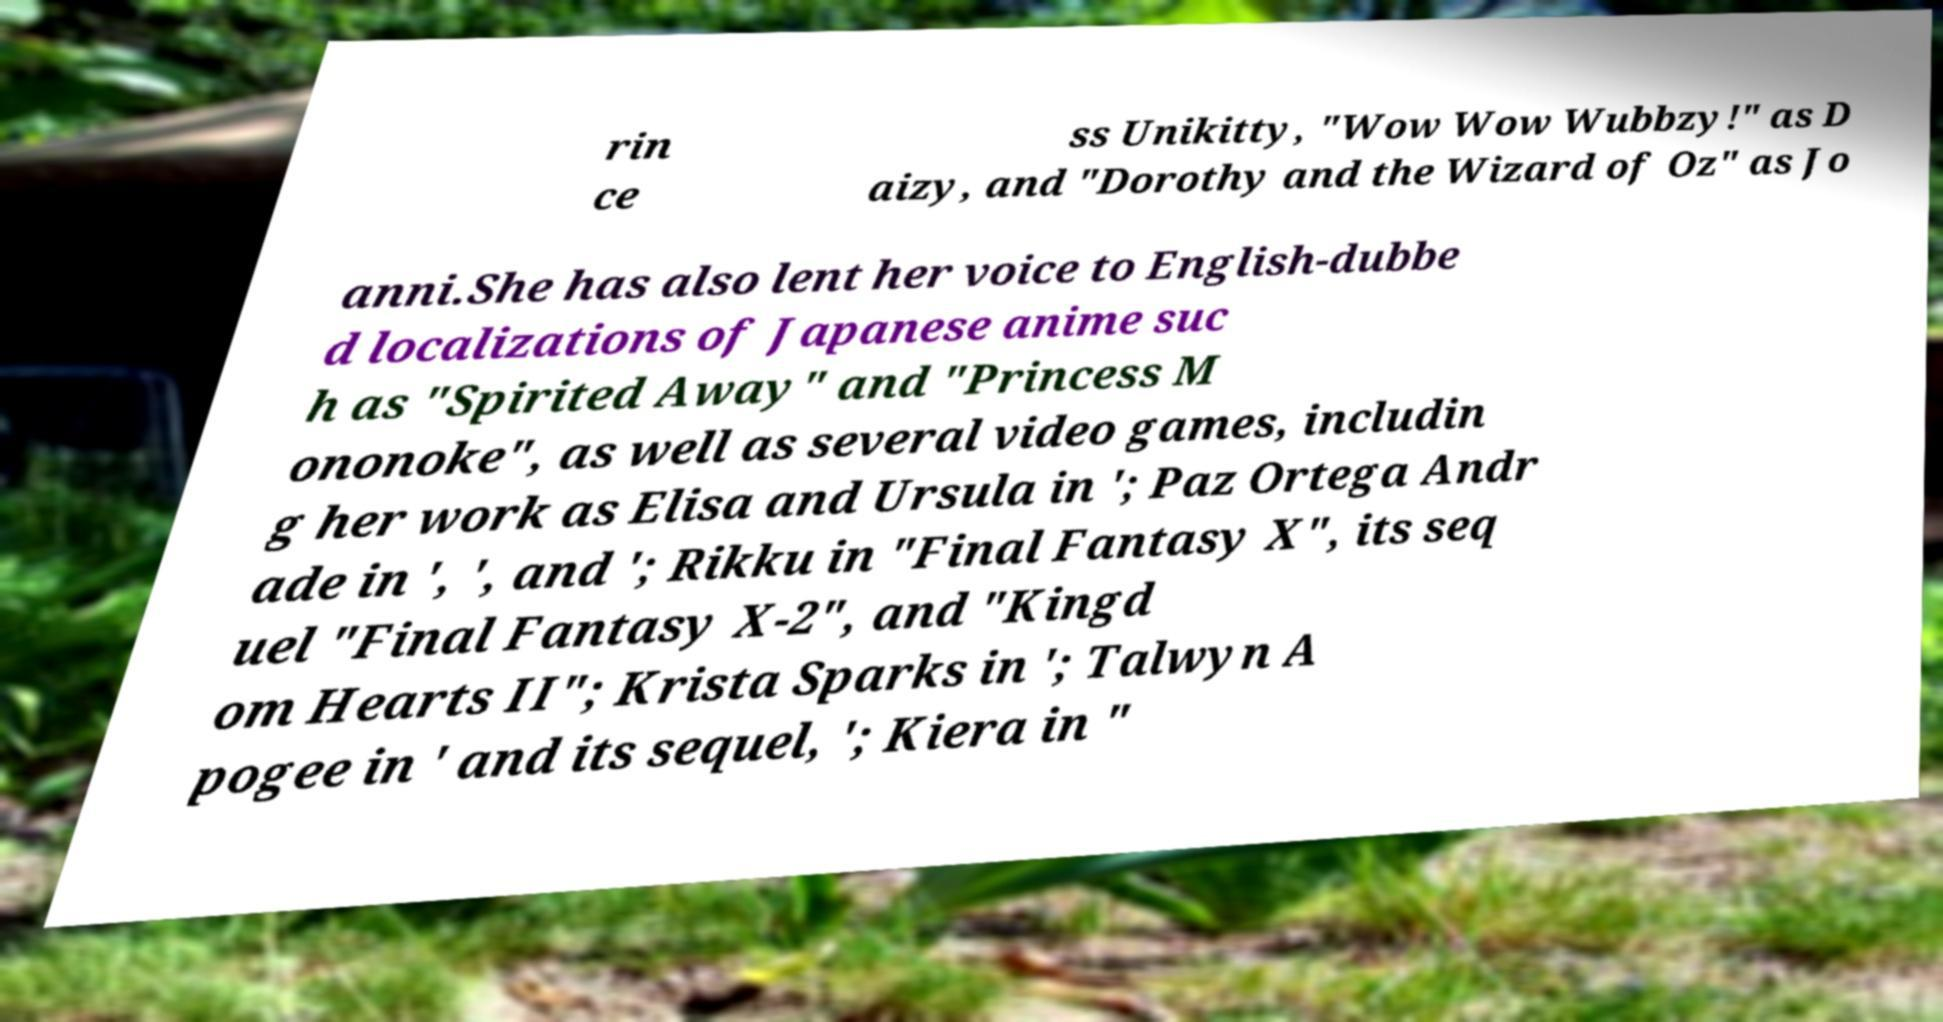Could you extract and type out the text from this image? rin ce ss Unikitty, "Wow Wow Wubbzy!" as D aizy, and "Dorothy and the Wizard of Oz" as Jo anni.She has also lent her voice to English-dubbe d localizations of Japanese anime suc h as "Spirited Away" and "Princess M ononoke", as well as several video games, includin g her work as Elisa and Ursula in '; Paz Ortega Andr ade in ', ', and '; Rikku in "Final Fantasy X", its seq uel "Final Fantasy X-2", and "Kingd om Hearts II"; Krista Sparks in '; Talwyn A pogee in ' and its sequel, '; Kiera in " 